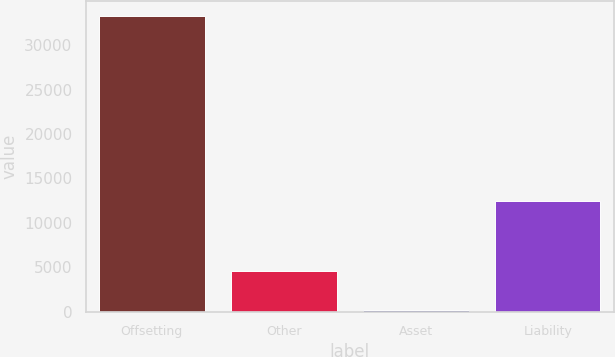<chart> <loc_0><loc_0><loc_500><loc_500><bar_chart><fcel>Offsetting<fcel>Other<fcel>Asset<fcel>Liability<nl><fcel>33266<fcel>4598<fcel>190<fcel>12485<nl></chart> 